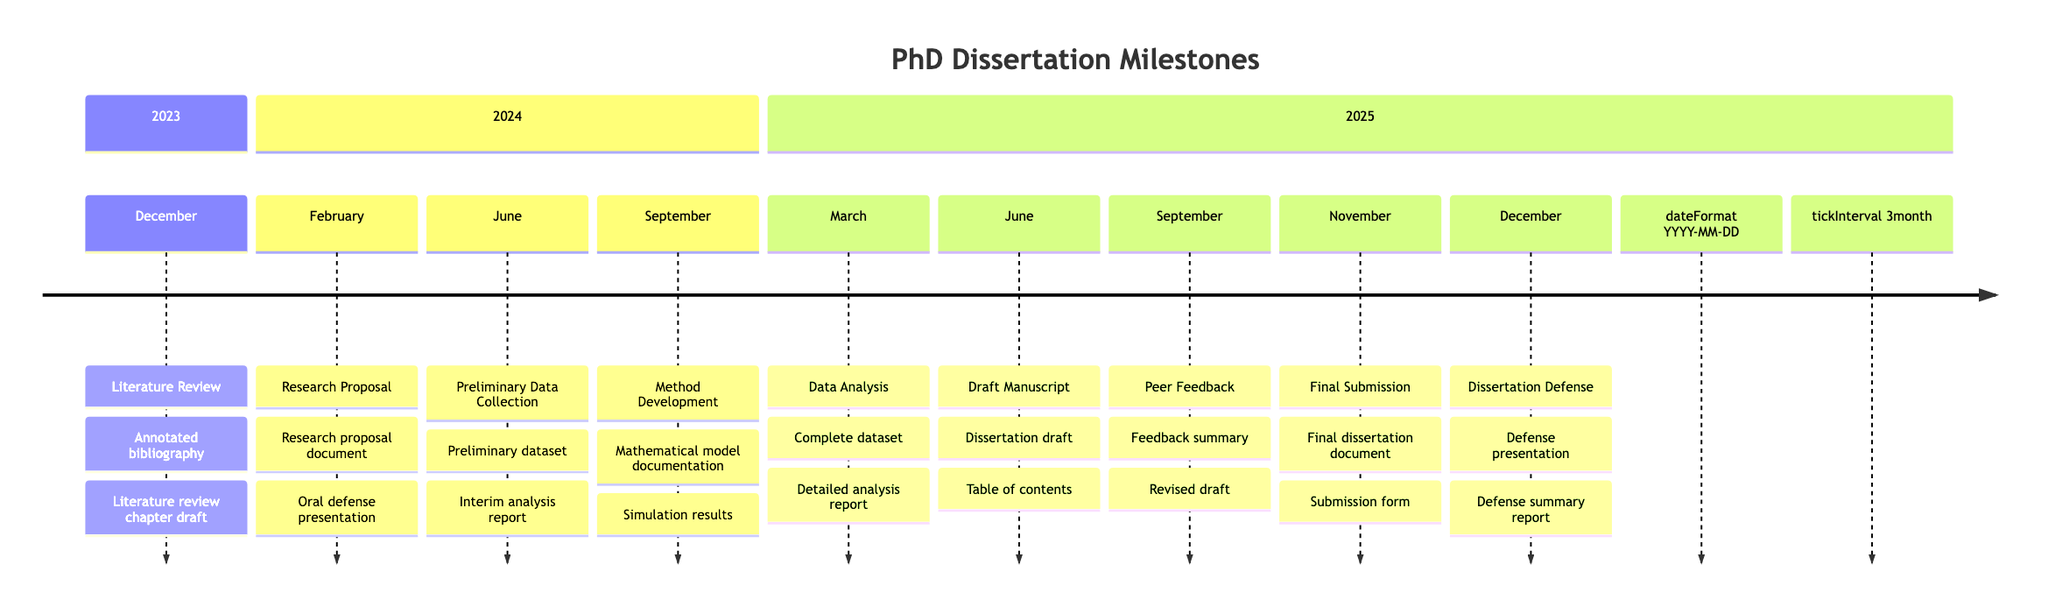What is the most immediate milestone after the Literature Review? The next milestone after the Literature Review is the Research Proposal, which is scheduled for February 2024.
Answer: Research Proposal How many deliverables are associated with the Preliminary Data Collection? The Preliminary Data Collection has two deliverables: the Preliminary dataset and the Interim analysis report.
Answer: 2 What month is the Draft Manuscript milestone scheduled for? The Draft Manuscript milestone is scheduled for June 2025, as indicated in the diagram timeline.
Answer: June Which milestone occurs in September 2024? The milestone that occurs in September 2024 is Method Development. It involves developing statistical models and methods.
Answer: Method Development What is the deadline for Final Submission of the dissertation? The deadline for the Final Submission of the dissertation is November 1, 2025, as shown on the timeline.
Answer: November 1, 2025 Which two deliverables are expected by the time of the Dissertation Defense? The deliverables expected by the time of the Dissertation Defense are the Defense presentation and the Defense summary report.
Answer: Defense presentation, Defense summary report How long is it between the Peer Feedback and Final Submission milestones? The time between the Peer Feedback milestone in September 2025 and the Final Submission in November 2025 is two months.
Answer: 2 months What is the sequence of the milestones listed in the diagram? The sequence of milestones is Literature Review, Research Proposal, Preliminary Data Collection, Method Development, Data Analysis, Draft Manuscript, Peer Feedback, Final Submission, Dissertation Defense.
Answer: Literature Review, Research Proposal, Preliminary Data Collection, Method Development, Data Analysis, Draft Manuscript, Peer Feedback, Final Submission, Dissertation Defense How many milestones are scheduled after Data Analysis? After Data Analysis, which has a deadline of March 15, 2025, there are three milestones scheduled: Draft Manuscript, Peer Feedback, and Final Submission.
Answer: 3 